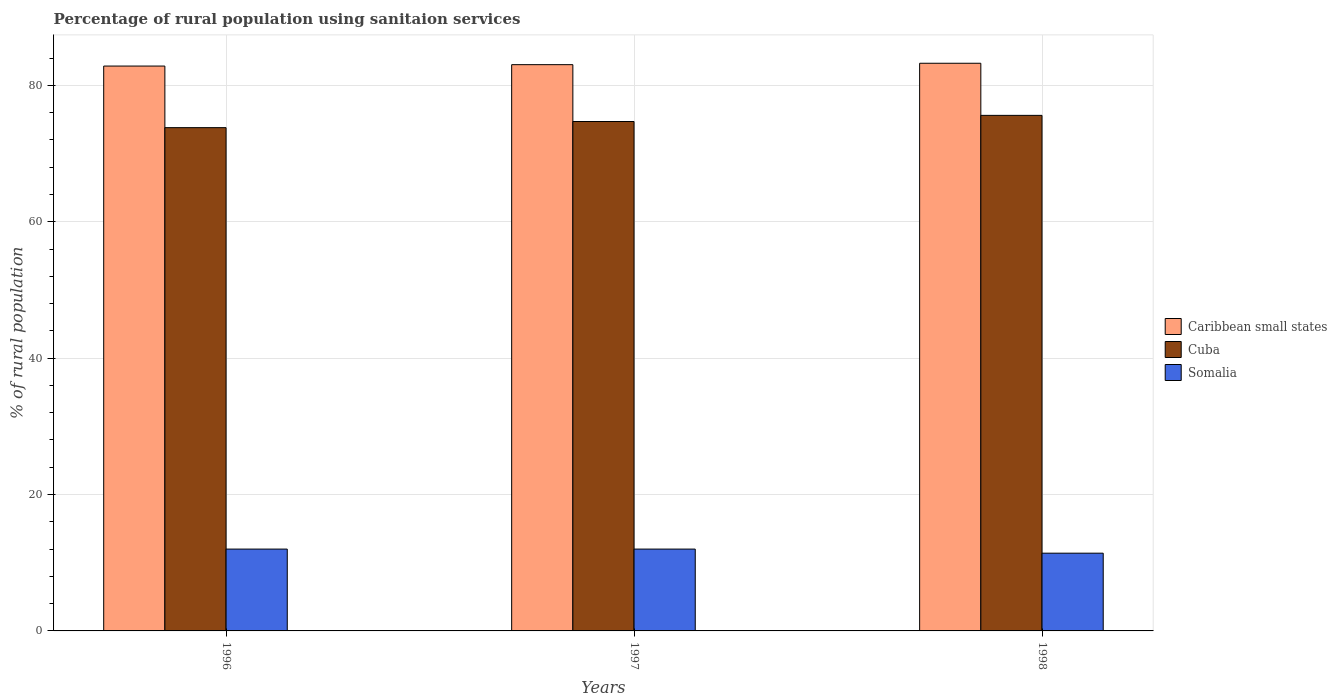How many bars are there on the 2nd tick from the left?
Provide a short and direct response. 3. How many bars are there on the 2nd tick from the right?
Offer a terse response. 3. What is the label of the 3rd group of bars from the left?
Provide a short and direct response. 1998. In how many cases, is the number of bars for a given year not equal to the number of legend labels?
Offer a terse response. 0. What is the percentage of rural population using sanitaion services in Caribbean small states in 1998?
Keep it short and to the point. 83.24. Across all years, what is the maximum percentage of rural population using sanitaion services in Cuba?
Your answer should be compact. 75.6. Across all years, what is the minimum percentage of rural population using sanitaion services in Caribbean small states?
Your answer should be very brief. 82.83. In which year was the percentage of rural population using sanitaion services in Somalia minimum?
Give a very brief answer. 1998. What is the total percentage of rural population using sanitaion services in Somalia in the graph?
Your answer should be very brief. 35.4. What is the difference between the percentage of rural population using sanitaion services in Caribbean small states in 1996 and that in 1997?
Your answer should be compact. -0.2. What is the difference between the percentage of rural population using sanitaion services in Cuba in 1998 and the percentage of rural population using sanitaion services in Caribbean small states in 1996?
Offer a very short reply. -7.23. What is the average percentage of rural population using sanitaion services in Somalia per year?
Make the answer very short. 11.8. In the year 1997, what is the difference between the percentage of rural population using sanitaion services in Caribbean small states and percentage of rural population using sanitaion services in Somalia?
Your answer should be compact. 71.04. In how many years, is the percentage of rural population using sanitaion services in Somalia greater than 28 %?
Make the answer very short. 0. What is the ratio of the percentage of rural population using sanitaion services in Cuba in 1997 to that in 1998?
Offer a terse response. 0.99. Is the difference between the percentage of rural population using sanitaion services in Caribbean small states in 1996 and 1998 greater than the difference between the percentage of rural population using sanitaion services in Somalia in 1996 and 1998?
Your response must be concise. No. What is the difference between the highest and the second highest percentage of rural population using sanitaion services in Cuba?
Your response must be concise. 0.9. What is the difference between the highest and the lowest percentage of rural population using sanitaion services in Caribbean small states?
Provide a short and direct response. 0.41. Is the sum of the percentage of rural population using sanitaion services in Cuba in 1996 and 1998 greater than the maximum percentage of rural population using sanitaion services in Somalia across all years?
Offer a very short reply. Yes. What does the 2nd bar from the left in 1997 represents?
Provide a short and direct response. Cuba. What does the 2nd bar from the right in 1996 represents?
Your answer should be compact. Cuba. Is it the case that in every year, the sum of the percentage of rural population using sanitaion services in Cuba and percentage of rural population using sanitaion services in Caribbean small states is greater than the percentage of rural population using sanitaion services in Somalia?
Your answer should be compact. Yes. How many bars are there?
Offer a terse response. 9. How many years are there in the graph?
Give a very brief answer. 3. What is the difference between two consecutive major ticks on the Y-axis?
Your response must be concise. 20. Are the values on the major ticks of Y-axis written in scientific E-notation?
Give a very brief answer. No. How are the legend labels stacked?
Provide a short and direct response. Vertical. What is the title of the graph?
Provide a succinct answer. Percentage of rural population using sanitaion services. Does "France" appear as one of the legend labels in the graph?
Your response must be concise. No. What is the label or title of the X-axis?
Ensure brevity in your answer.  Years. What is the label or title of the Y-axis?
Offer a terse response. % of rural population. What is the % of rural population of Caribbean small states in 1996?
Your response must be concise. 82.83. What is the % of rural population of Cuba in 1996?
Your answer should be compact. 73.8. What is the % of rural population of Somalia in 1996?
Your response must be concise. 12. What is the % of rural population in Caribbean small states in 1997?
Keep it short and to the point. 83.04. What is the % of rural population in Cuba in 1997?
Keep it short and to the point. 74.7. What is the % of rural population in Caribbean small states in 1998?
Your answer should be compact. 83.24. What is the % of rural population in Cuba in 1998?
Provide a succinct answer. 75.6. Across all years, what is the maximum % of rural population of Caribbean small states?
Ensure brevity in your answer.  83.24. Across all years, what is the maximum % of rural population of Cuba?
Keep it short and to the point. 75.6. Across all years, what is the maximum % of rural population in Somalia?
Ensure brevity in your answer.  12. Across all years, what is the minimum % of rural population of Caribbean small states?
Your answer should be compact. 82.83. Across all years, what is the minimum % of rural population in Cuba?
Your answer should be compact. 73.8. What is the total % of rural population of Caribbean small states in the graph?
Keep it short and to the point. 249.11. What is the total % of rural population in Cuba in the graph?
Your answer should be compact. 224.1. What is the total % of rural population of Somalia in the graph?
Make the answer very short. 35.4. What is the difference between the % of rural population of Caribbean small states in 1996 and that in 1997?
Your response must be concise. -0.2. What is the difference between the % of rural population in Cuba in 1996 and that in 1997?
Your response must be concise. -0.9. What is the difference between the % of rural population in Caribbean small states in 1996 and that in 1998?
Offer a terse response. -0.41. What is the difference between the % of rural population of Cuba in 1996 and that in 1998?
Your answer should be very brief. -1.8. What is the difference between the % of rural population of Somalia in 1996 and that in 1998?
Ensure brevity in your answer.  0.6. What is the difference between the % of rural population of Caribbean small states in 1997 and that in 1998?
Give a very brief answer. -0.21. What is the difference between the % of rural population of Caribbean small states in 1996 and the % of rural population of Cuba in 1997?
Provide a succinct answer. 8.13. What is the difference between the % of rural population in Caribbean small states in 1996 and the % of rural population in Somalia in 1997?
Your answer should be very brief. 70.83. What is the difference between the % of rural population of Cuba in 1996 and the % of rural population of Somalia in 1997?
Offer a terse response. 61.8. What is the difference between the % of rural population in Caribbean small states in 1996 and the % of rural population in Cuba in 1998?
Ensure brevity in your answer.  7.23. What is the difference between the % of rural population of Caribbean small states in 1996 and the % of rural population of Somalia in 1998?
Provide a succinct answer. 71.43. What is the difference between the % of rural population of Cuba in 1996 and the % of rural population of Somalia in 1998?
Give a very brief answer. 62.4. What is the difference between the % of rural population of Caribbean small states in 1997 and the % of rural population of Cuba in 1998?
Your response must be concise. 7.44. What is the difference between the % of rural population in Caribbean small states in 1997 and the % of rural population in Somalia in 1998?
Ensure brevity in your answer.  71.64. What is the difference between the % of rural population in Cuba in 1997 and the % of rural population in Somalia in 1998?
Offer a terse response. 63.3. What is the average % of rural population of Caribbean small states per year?
Provide a short and direct response. 83.04. What is the average % of rural population of Cuba per year?
Your response must be concise. 74.7. What is the average % of rural population in Somalia per year?
Keep it short and to the point. 11.8. In the year 1996, what is the difference between the % of rural population of Caribbean small states and % of rural population of Cuba?
Give a very brief answer. 9.03. In the year 1996, what is the difference between the % of rural population of Caribbean small states and % of rural population of Somalia?
Offer a very short reply. 70.83. In the year 1996, what is the difference between the % of rural population of Cuba and % of rural population of Somalia?
Offer a very short reply. 61.8. In the year 1997, what is the difference between the % of rural population in Caribbean small states and % of rural population in Cuba?
Offer a very short reply. 8.34. In the year 1997, what is the difference between the % of rural population in Caribbean small states and % of rural population in Somalia?
Make the answer very short. 71.04. In the year 1997, what is the difference between the % of rural population in Cuba and % of rural population in Somalia?
Ensure brevity in your answer.  62.7. In the year 1998, what is the difference between the % of rural population of Caribbean small states and % of rural population of Cuba?
Ensure brevity in your answer.  7.64. In the year 1998, what is the difference between the % of rural population in Caribbean small states and % of rural population in Somalia?
Your answer should be very brief. 71.84. In the year 1998, what is the difference between the % of rural population in Cuba and % of rural population in Somalia?
Offer a terse response. 64.2. What is the ratio of the % of rural population of Caribbean small states in 1996 to that in 1998?
Offer a terse response. 1. What is the ratio of the % of rural population in Cuba in 1996 to that in 1998?
Make the answer very short. 0.98. What is the ratio of the % of rural population of Somalia in 1996 to that in 1998?
Your answer should be very brief. 1.05. What is the ratio of the % of rural population in Caribbean small states in 1997 to that in 1998?
Offer a very short reply. 1. What is the ratio of the % of rural population in Somalia in 1997 to that in 1998?
Offer a very short reply. 1.05. What is the difference between the highest and the second highest % of rural population in Caribbean small states?
Offer a terse response. 0.21. What is the difference between the highest and the lowest % of rural population of Caribbean small states?
Your answer should be very brief. 0.41. What is the difference between the highest and the lowest % of rural population in Cuba?
Your answer should be compact. 1.8. 